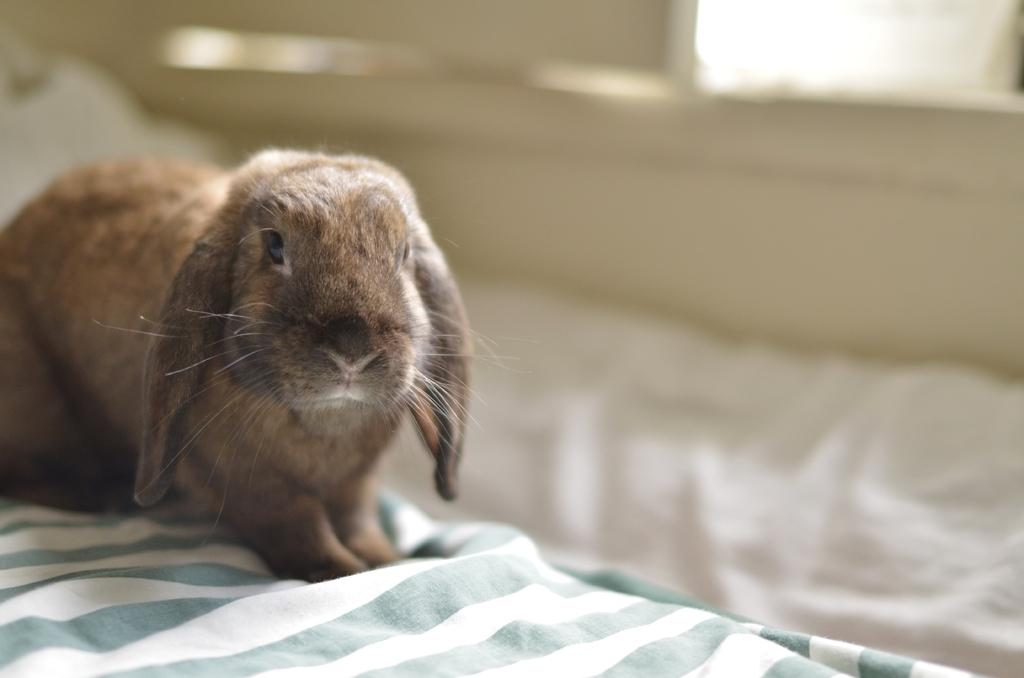What type of animal is in the image? There is a brown rabbit in the image. Where is the rabbit located? The rabbit is sitting on a bed sheet. Can you describe the background of the image? The background of the image is blurred. What type of food is the rabbit holding in its paws in the image? There is no food visible in the image; the rabbit is not holding anything in its paws. 